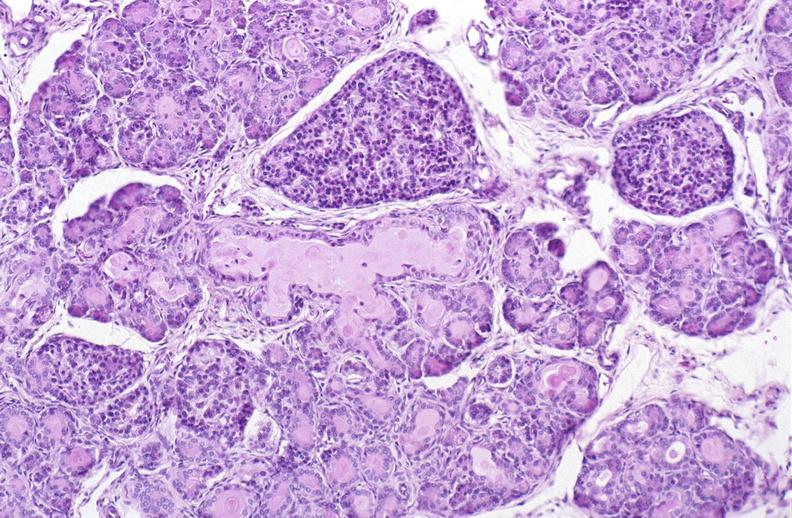s pancreas present?
Answer the question using a single word or phrase. Yes 